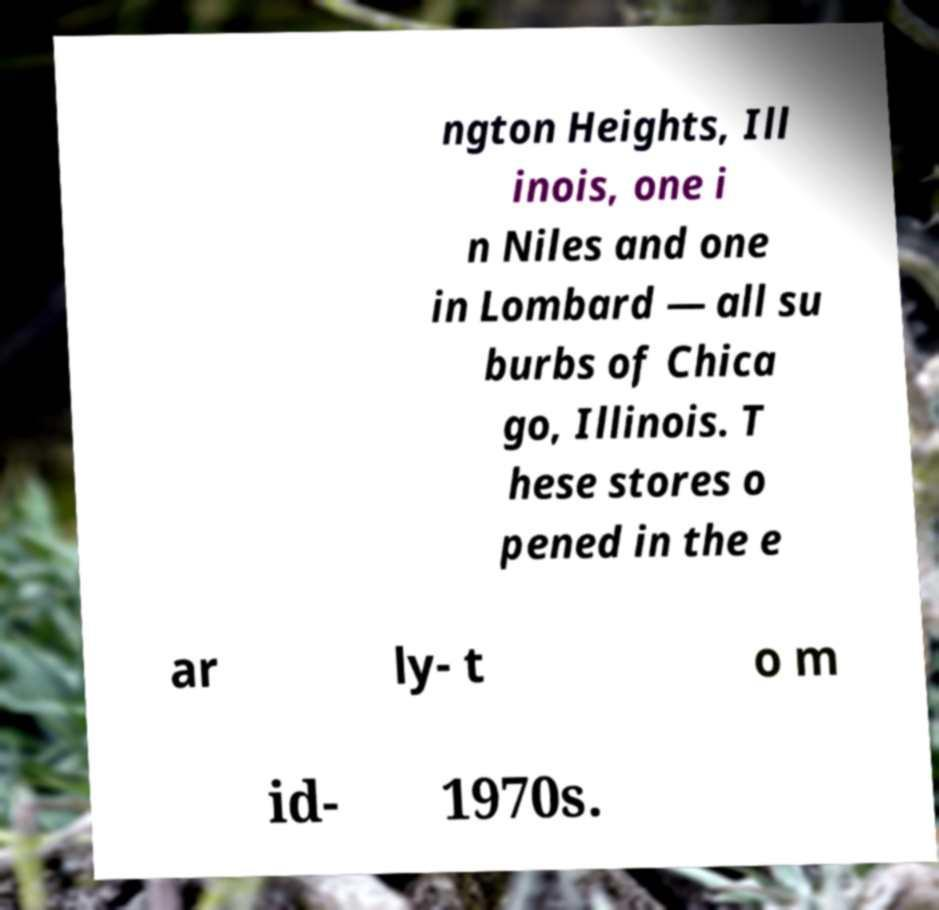Could you assist in decoding the text presented in this image and type it out clearly? ngton Heights, Ill inois, one i n Niles and one in Lombard — all su burbs of Chica go, Illinois. T hese stores o pened in the e ar ly- t o m id- 1970s. 